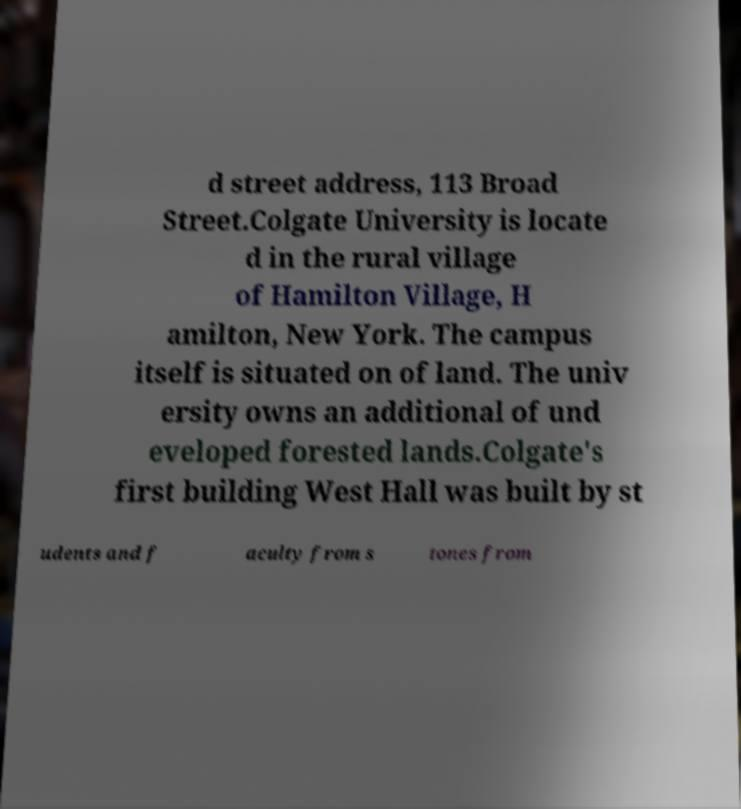For documentation purposes, I need the text within this image transcribed. Could you provide that? d street address, 113 Broad Street.Colgate University is locate d in the rural village of Hamilton Village, H amilton, New York. The campus itself is situated on of land. The univ ersity owns an additional of und eveloped forested lands.Colgate's first building West Hall was built by st udents and f aculty from s tones from 